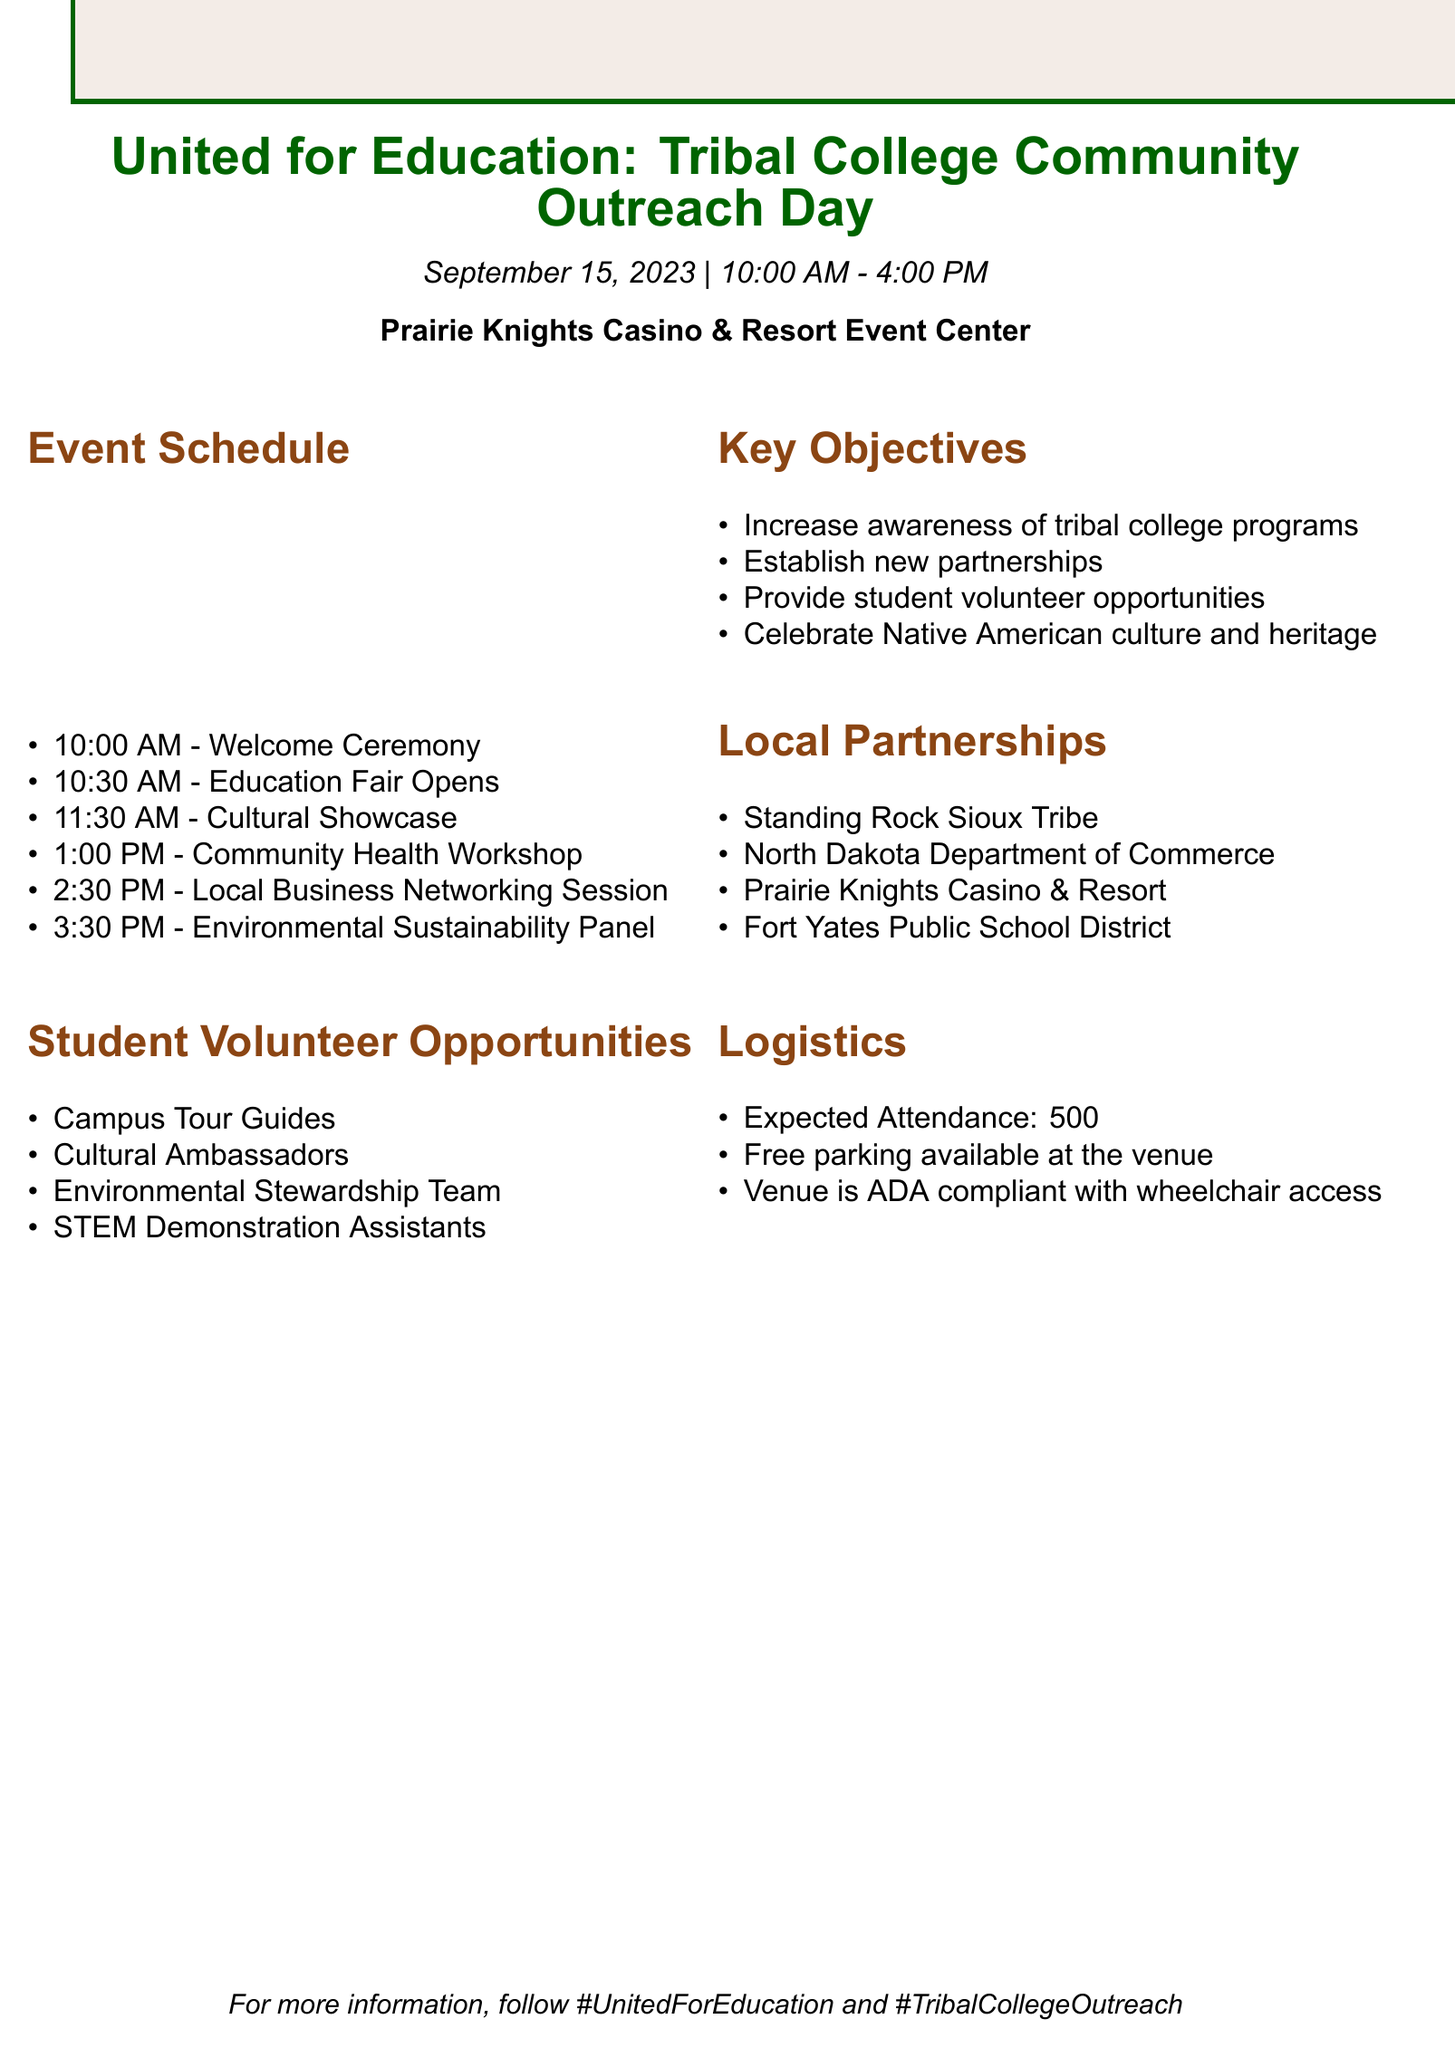What is the event title? The event title is prominently displayed at the top of the document, which is "United for Education: Tribal College Community Outreach Day."
Answer: United for Education: Tribal College Community Outreach Day What date is the event scheduled? The event date is listed under the event description section, which states "September 15, 2023."
Answer: September 15, 2023 Who provides cultural presentations? The local partnerships section mentions that the "Standing Rock Sioux Tribe" will provide cultural presentations and traditional food demonstrations.
Answer: Standing Rock Sioux Tribe What is the expected attendance for the event? The logistics section clearly specifies the expected attendance as "500."
Answer: 500 Name one student volunteer opportunity available. The section on student volunteer opportunities lists several roles; one example is "Campus Tour Guides."
Answer: Campus Tour Guides Which panel focuses on preserving tribal lands? In the event components, the panel that addresses this topic is titled "Environmental Sustainability Panel."
Answer: Environmental Sustainability Panel What is one of the marketing strategies mentioned? The marketing strategies outlined include collaboration with KLND 89.5 FM Tribal Radio for event promotion.
Answer: Collaborate with KLND 89.5 FM Tribal Radio What time does the Education Fair open? The event schedule outlines that the "Education Fair Opens" at 10:30 AM.
Answer: 10:30 AM What is part of the post-event activities? One of the post-event activities includes "Thank you letters to sponsors and participating organizations."
Answer: Thank you letters to sponsors and participating organizations 